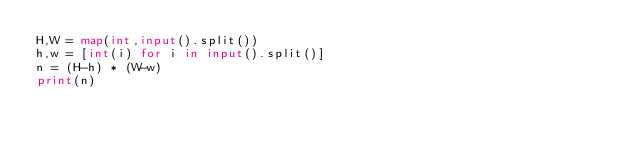<code> <loc_0><loc_0><loc_500><loc_500><_Python_>H,W = map(int,input().split())
h,w = [int(i) for i in input().split()]
n = (H-h) * (W-w)
print(n)
</code> 